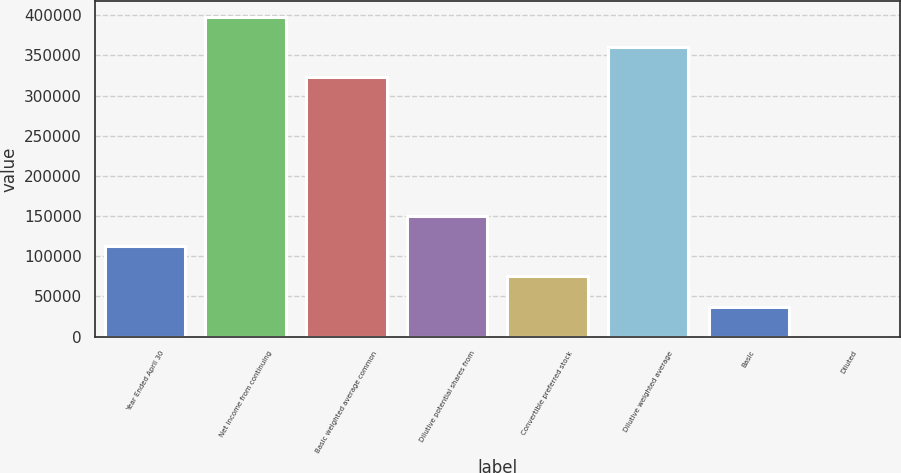<chart> <loc_0><loc_0><loc_500><loc_500><bar_chart><fcel>Year Ended April 30<fcel>Net income from continuing<fcel>Basic weighted average common<fcel>Dilutive potential shares from<fcel>Convertible preferred stock<fcel>Dilutive weighted average<fcel>Basic<fcel>Diluted<nl><fcel>112302<fcel>397555<fcel>322688<fcel>149735<fcel>74868.3<fcel>360122<fcel>37434.7<fcel>1.15<nl></chart> 